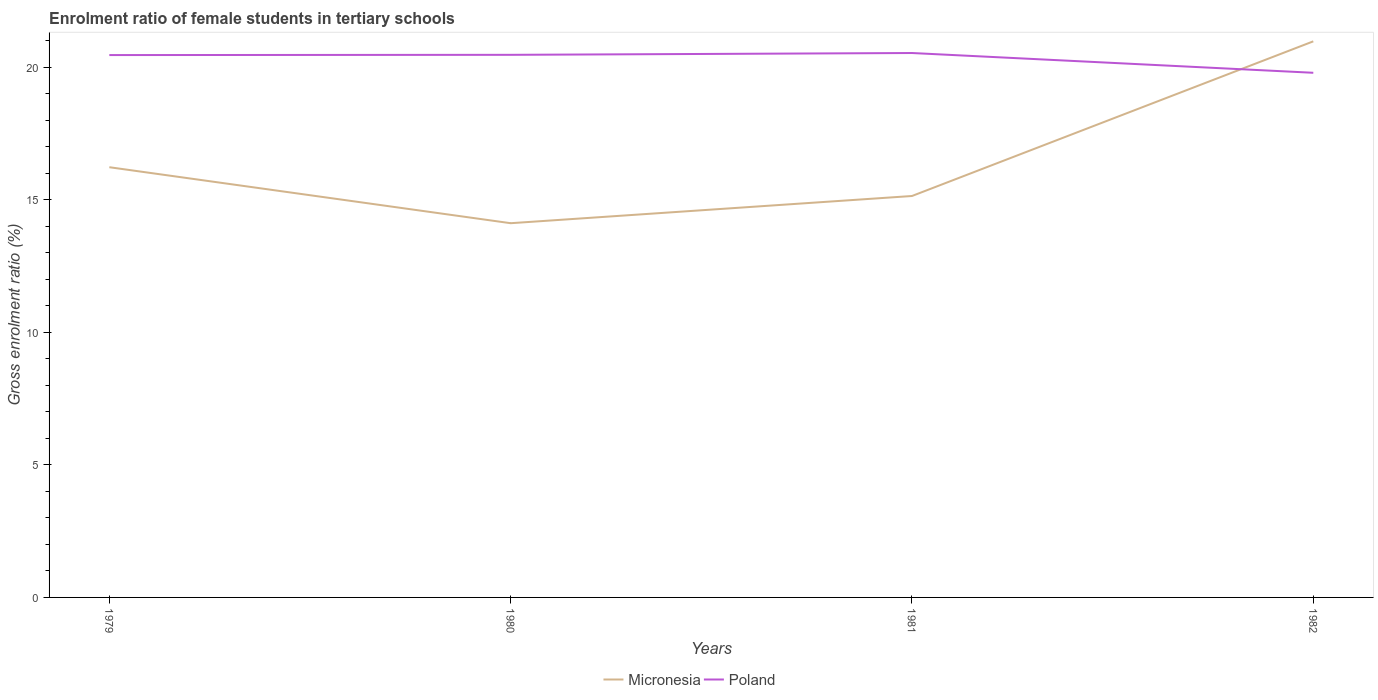How many different coloured lines are there?
Your answer should be very brief. 2. Across all years, what is the maximum enrolment ratio of female students in tertiary schools in Poland?
Give a very brief answer. 19.79. What is the total enrolment ratio of female students in tertiary schools in Poland in the graph?
Offer a terse response. -0.08. What is the difference between the highest and the second highest enrolment ratio of female students in tertiary schools in Poland?
Keep it short and to the point. 0.75. What is the difference between the highest and the lowest enrolment ratio of female students in tertiary schools in Micronesia?
Offer a very short reply. 1. What is the difference between two consecutive major ticks on the Y-axis?
Provide a short and direct response. 5. Where does the legend appear in the graph?
Offer a very short reply. Bottom center. How many legend labels are there?
Your answer should be very brief. 2. What is the title of the graph?
Keep it short and to the point. Enrolment ratio of female students in tertiary schools. Does "Small states" appear as one of the legend labels in the graph?
Your response must be concise. No. What is the label or title of the Y-axis?
Your answer should be compact. Gross enrolment ratio (%). What is the Gross enrolment ratio (%) in Micronesia in 1979?
Provide a short and direct response. 16.23. What is the Gross enrolment ratio (%) in Poland in 1979?
Offer a terse response. 20.46. What is the Gross enrolment ratio (%) in Micronesia in 1980?
Offer a very short reply. 14.12. What is the Gross enrolment ratio (%) of Poland in 1980?
Provide a succinct answer. 20.47. What is the Gross enrolment ratio (%) of Micronesia in 1981?
Ensure brevity in your answer.  15.14. What is the Gross enrolment ratio (%) in Poland in 1981?
Offer a terse response. 20.54. What is the Gross enrolment ratio (%) of Micronesia in 1982?
Offer a terse response. 20.98. What is the Gross enrolment ratio (%) of Poland in 1982?
Your answer should be compact. 19.79. Across all years, what is the maximum Gross enrolment ratio (%) in Micronesia?
Your response must be concise. 20.98. Across all years, what is the maximum Gross enrolment ratio (%) in Poland?
Ensure brevity in your answer.  20.54. Across all years, what is the minimum Gross enrolment ratio (%) in Micronesia?
Make the answer very short. 14.12. Across all years, what is the minimum Gross enrolment ratio (%) of Poland?
Your answer should be very brief. 19.79. What is the total Gross enrolment ratio (%) of Micronesia in the graph?
Your answer should be compact. 66.47. What is the total Gross enrolment ratio (%) of Poland in the graph?
Your answer should be compact. 81.26. What is the difference between the Gross enrolment ratio (%) of Micronesia in 1979 and that in 1980?
Your answer should be very brief. 2.11. What is the difference between the Gross enrolment ratio (%) in Poland in 1979 and that in 1980?
Give a very brief answer. -0.01. What is the difference between the Gross enrolment ratio (%) in Micronesia in 1979 and that in 1981?
Keep it short and to the point. 1.09. What is the difference between the Gross enrolment ratio (%) of Poland in 1979 and that in 1981?
Offer a very short reply. -0.08. What is the difference between the Gross enrolment ratio (%) in Micronesia in 1979 and that in 1982?
Ensure brevity in your answer.  -4.75. What is the difference between the Gross enrolment ratio (%) of Poland in 1979 and that in 1982?
Your answer should be very brief. 0.67. What is the difference between the Gross enrolment ratio (%) of Micronesia in 1980 and that in 1981?
Offer a very short reply. -1.03. What is the difference between the Gross enrolment ratio (%) in Poland in 1980 and that in 1981?
Make the answer very short. -0.07. What is the difference between the Gross enrolment ratio (%) in Micronesia in 1980 and that in 1982?
Keep it short and to the point. -6.86. What is the difference between the Gross enrolment ratio (%) of Poland in 1980 and that in 1982?
Your answer should be very brief. 0.68. What is the difference between the Gross enrolment ratio (%) of Micronesia in 1981 and that in 1982?
Give a very brief answer. -5.83. What is the difference between the Gross enrolment ratio (%) in Poland in 1981 and that in 1982?
Your response must be concise. 0.75. What is the difference between the Gross enrolment ratio (%) of Micronesia in 1979 and the Gross enrolment ratio (%) of Poland in 1980?
Ensure brevity in your answer.  -4.24. What is the difference between the Gross enrolment ratio (%) of Micronesia in 1979 and the Gross enrolment ratio (%) of Poland in 1981?
Your answer should be compact. -4.31. What is the difference between the Gross enrolment ratio (%) in Micronesia in 1979 and the Gross enrolment ratio (%) in Poland in 1982?
Your answer should be very brief. -3.56. What is the difference between the Gross enrolment ratio (%) in Micronesia in 1980 and the Gross enrolment ratio (%) in Poland in 1981?
Give a very brief answer. -6.42. What is the difference between the Gross enrolment ratio (%) in Micronesia in 1980 and the Gross enrolment ratio (%) in Poland in 1982?
Your response must be concise. -5.67. What is the difference between the Gross enrolment ratio (%) of Micronesia in 1981 and the Gross enrolment ratio (%) of Poland in 1982?
Your answer should be very brief. -4.65. What is the average Gross enrolment ratio (%) in Micronesia per year?
Make the answer very short. 16.62. What is the average Gross enrolment ratio (%) of Poland per year?
Your response must be concise. 20.32. In the year 1979, what is the difference between the Gross enrolment ratio (%) in Micronesia and Gross enrolment ratio (%) in Poland?
Your answer should be very brief. -4.23. In the year 1980, what is the difference between the Gross enrolment ratio (%) of Micronesia and Gross enrolment ratio (%) of Poland?
Offer a very short reply. -6.35. In the year 1981, what is the difference between the Gross enrolment ratio (%) in Micronesia and Gross enrolment ratio (%) in Poland?
Your response must be concise. -5.39. In the year 1982, what is the difference between the Gross enrolment ratio (%) of Micronesia and Gross enrolment ratio (%) of Poland?
Provide a short and direct response. 1.19. What is the ratio of the Gross enrolment ratio (%) of Micronesia in 1979 to that in 1980?
Provide a short and direct response. 1.15. What is the ratio of the Gross enrolment ratio (%) of Poland in 1979 to that in 1980?
Provide a succinct answer. 1. What is the ratio of the Gross enrolment ratio (%) in Micronesia in 1979 to that in 1981?
Offer a terse response. 1.07. What is the ratio of the Gross enrolment ratio (%) of Poland in 1979 to that in 1981?
Give a very brief answer. 1. What is the ratio of the Gross enrolment ratio (%) in Micronesia in 1979 to that in 1982?
Your answer should be compact. 0.77. What is the ratio of the Gross enrolment ratio (%) of Poland in 1979 to that in 1982?
Provide a short and direct response. 1.03. What is the ratio of the Gross enrolment ratio (%) of Micronesia in 1980 to that in 1981?
Provide a short and direct response. 0.93. What is the ratio of the Gross enrolment ratio (%) in Poland in 1980 to that in 1981?
Ensure brevity in your answer.  1. What is the ratio of the Gross enrolment ratio (%) in Micronesia in 1980 to that in 1982?
Give a very brief answer. 0.67. What is the ratio of the Gross enrolment ratio (%) in Poland in 1980 to that in 1982?
Keep it short and to the point. 1.03. What is the ratio of the Gross enrolment ratio (%) of Micronesia in 1981 to that in 1982?
Provide a succinct answer. 0.72. What is the ratio of the Gross enrolment ratio (%) of Poland in 1981 to that in 1982?
Your response must be concise. 1.04. What is the difference between the highest and the second highest Gross enrolment ratio (%) of Micronesia?
Offer a very short reply. 4.75. What is the difference between the highest and the second highest Gross enrolment ratio (%) of Poland?
Offer a terse response. 0.07. What is the difference between the highest and the lowest Gross enrolment ratio (%) of Micronesia?
Your answer should be compact. 6.86. What is the difference between the highest and the lowest Gross enrolment ratio (%) in Poland?
Offer a very short reply. 0.75. 